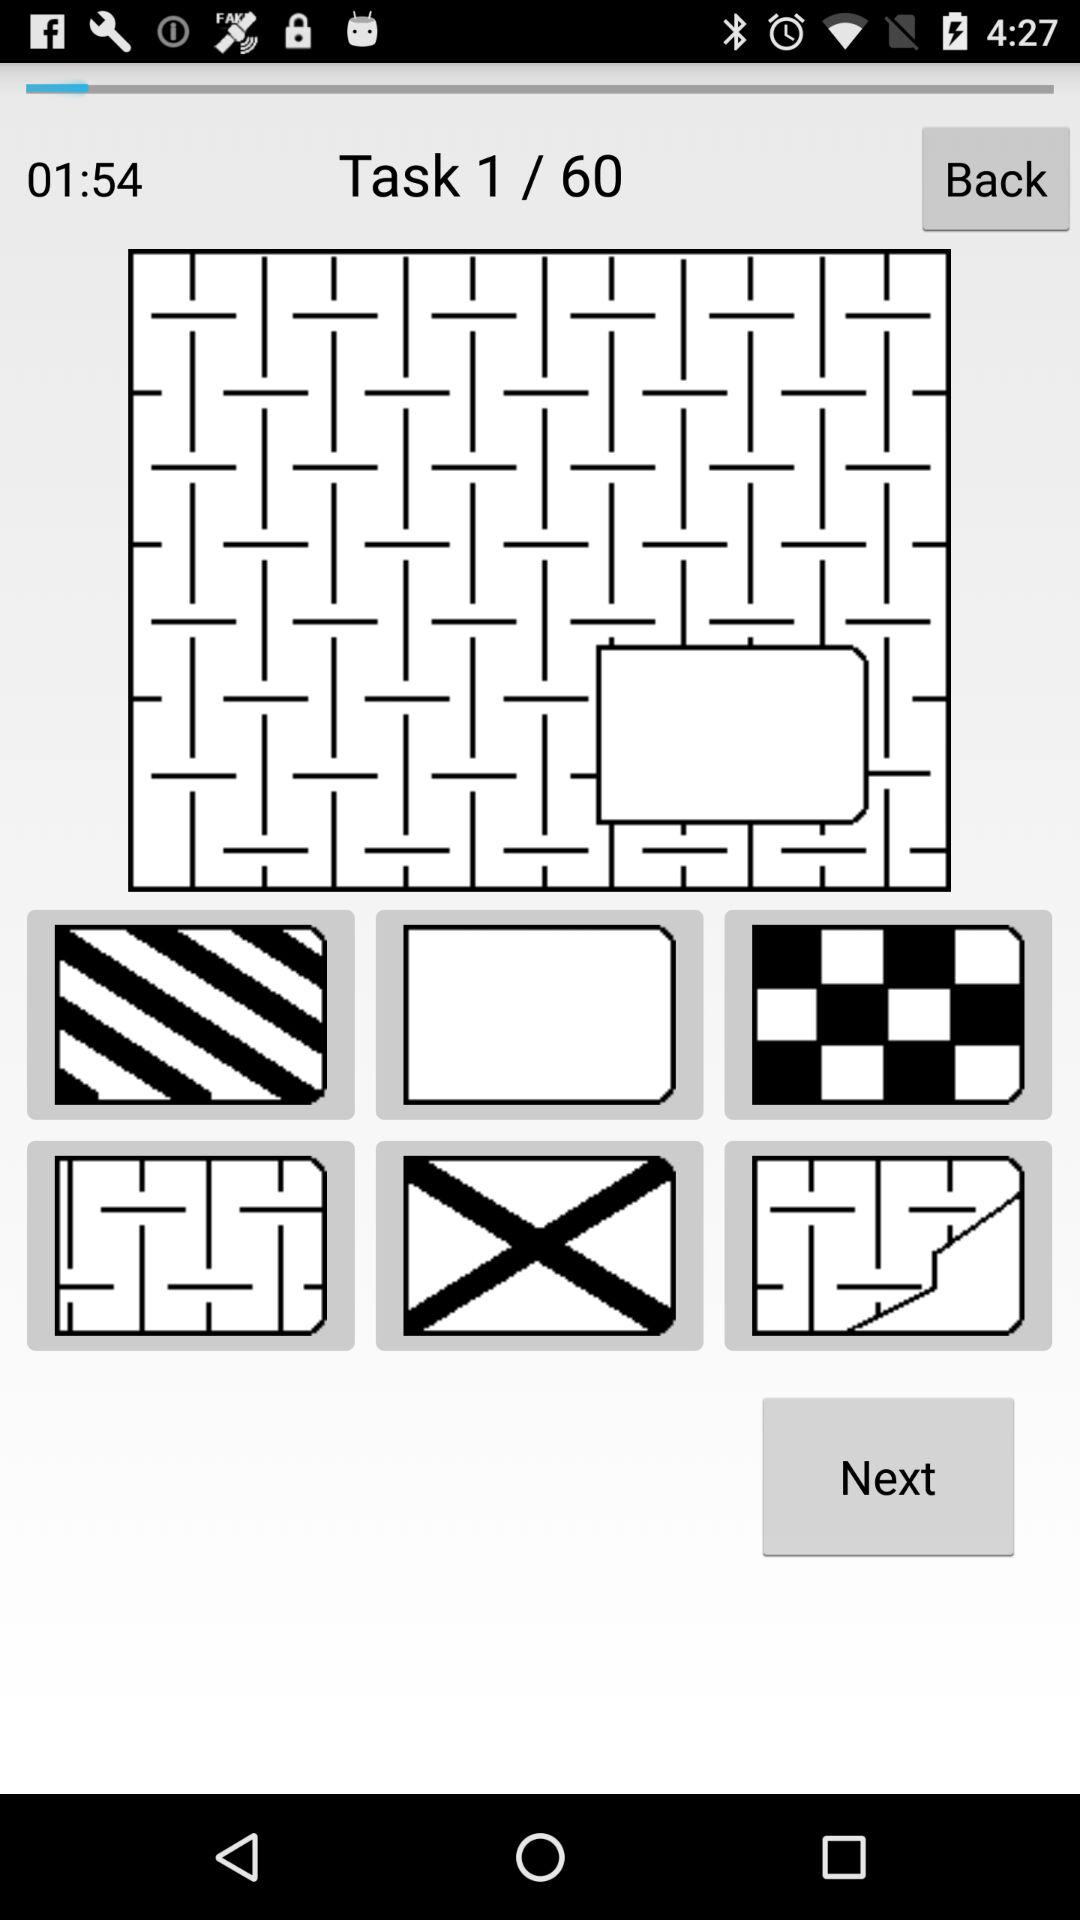How many pages are there in total? There are 60 pages. 